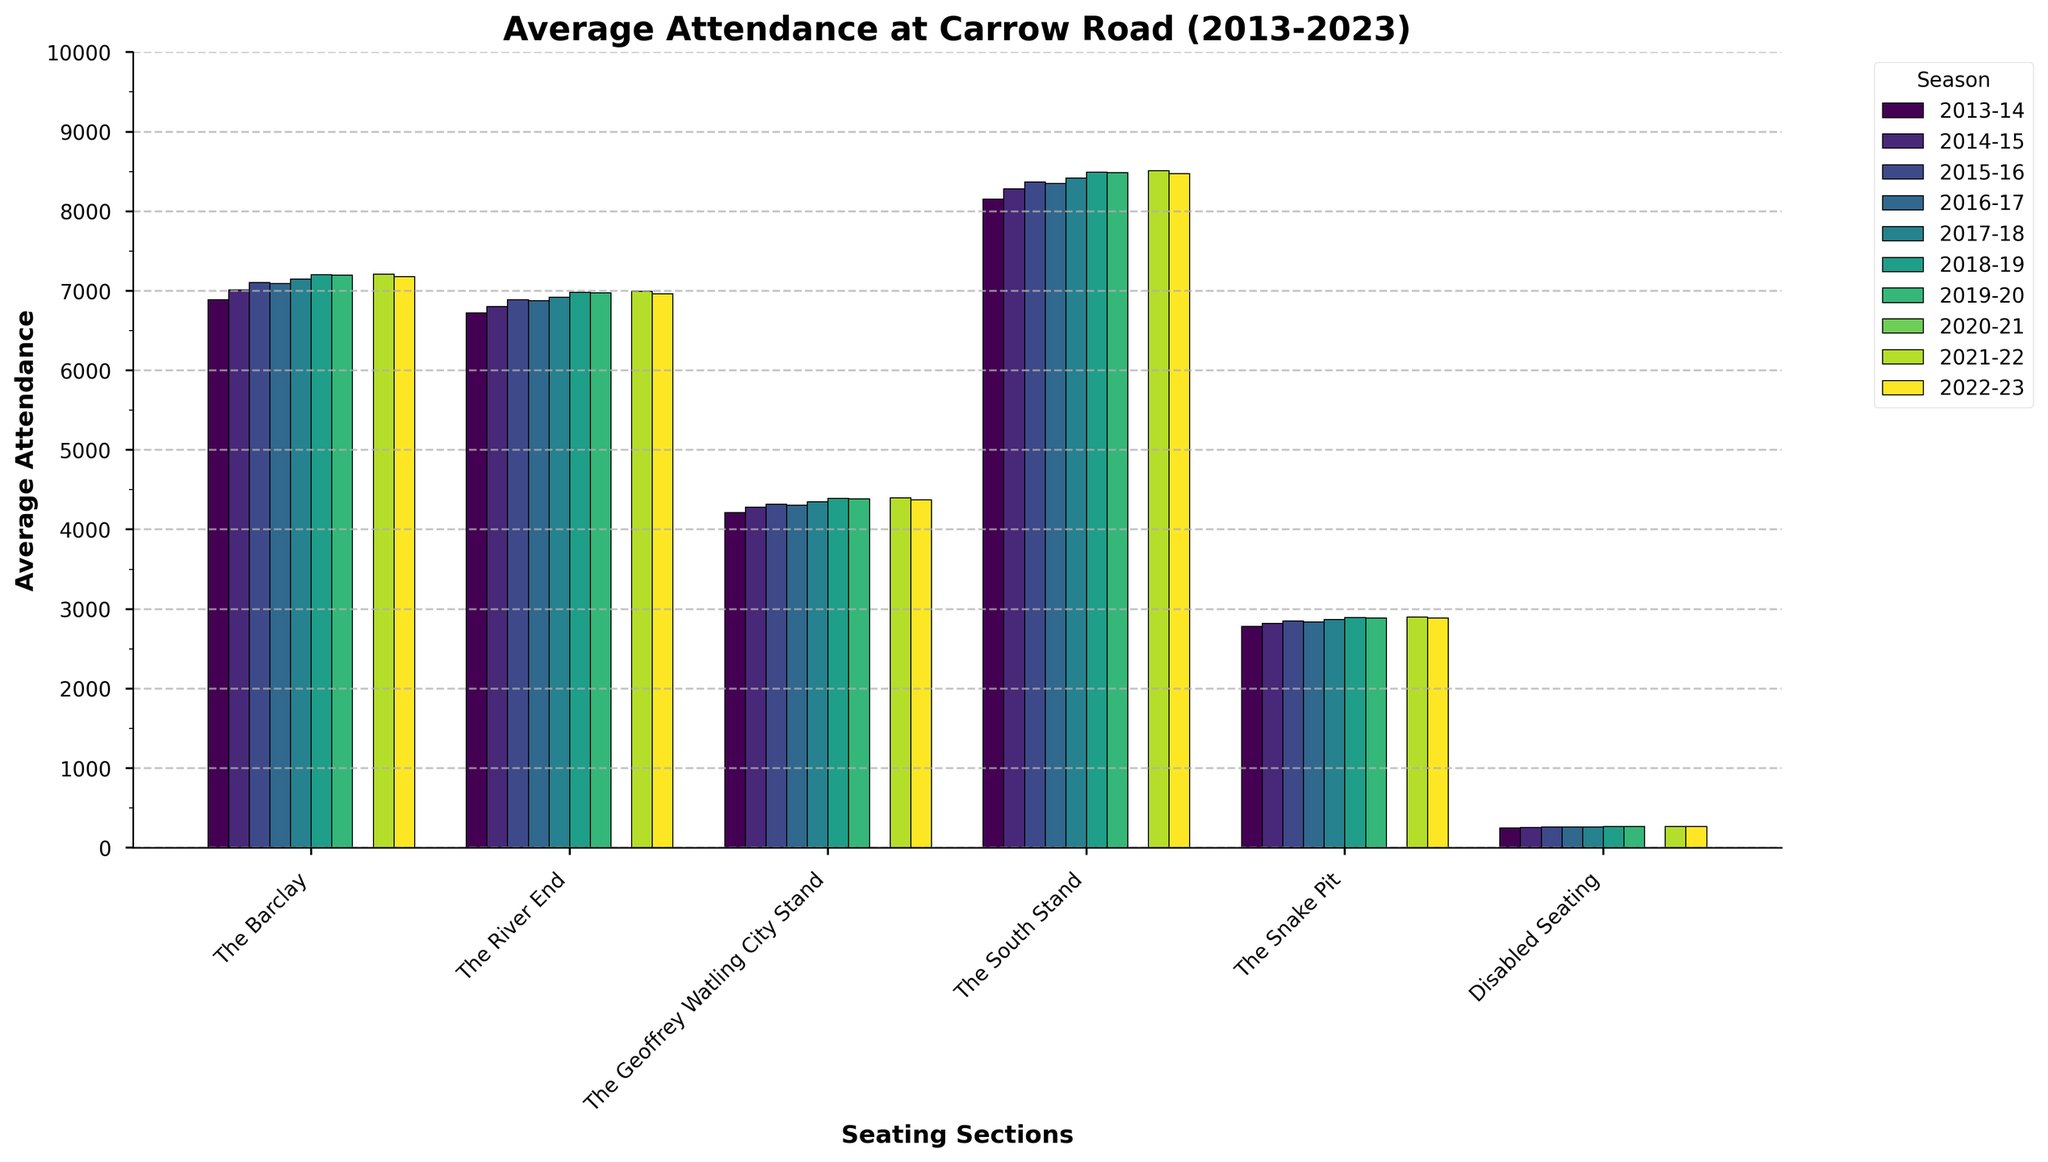What is the average attendance in 'The South Stand' for the 2022-23 season? Locate 'The South Stand' section and the bar representing the 2022-23 season. The average attendance is given at the top of the bar.
Answer: 8470 Which section had the highest average attendance in the 2015-16 season? Compare the heights of the bars for each section in the 2015-16 season. The section with the tallest bar has the highest attendance.
Answer: The South Stand How did the attendance in 'The Barclay' change from 2013-14 to 2014-15? Locate the bars for 'The Barclay' in the 2013-14 and 2014-15 seasons and compare their heights. Subtract the attendance of 2013-14 from the attendance of 2014-15.
Answer: Increased by 122 Which section saw the most significant decrease in attendance from 2018-19 to 2019-20? Compare the bars of each section between 2018-19 and 2019-20 and determine the section with the largest decrease in bar height.
Answer: The Barclay What was the total average attendance for 'The Snake Pit' across the first five seasons shown? Add the average attendance figures of 'The Snake Pit' from 2013-14 to 2017-18.
Answer: 14160 Between 'The River End' and 'The Geoffrey Watling City Stand', which section had a more consistent average attendance over the decade? Compare the range of attendance values for each section over the decade. The section with the smaller range (difference between max and min) is more consistent.
Answer: The Geoffrey Watling City Stand What's the combined attendance for 'The Barclay' and 'The River End' in 2017-18? Locate the attendance figures for 'The Barclay' and 'The River End' in the 2017-18 season and add them together.
Answer: 14070 In the 2021-22 season, which section had the lowest attendance? Locate the bars for the 2021-22 season and identify the shortest bar, which represents the lowest attendance.
Answer: Disabled Seating If the seating capacity for 'Disabled Seating' is 300, what was the occupancy rate in the 2022-23 season? Divide the attendance figure for 'Disabled Seating' in the 2022-23 season by the seating capacity (300) and multiply by 100 to get the percentage.
Answer: 88.67% Between 'The South Stand' and 'The River End', which showed a greater increase in attendance from 2015-16 to 2022-23? Calculate the difference in attendance for 'The South Stand' and 'The River End' between 2015-16 and 2022-23 and compare the two values.
Answer: The South Stand 